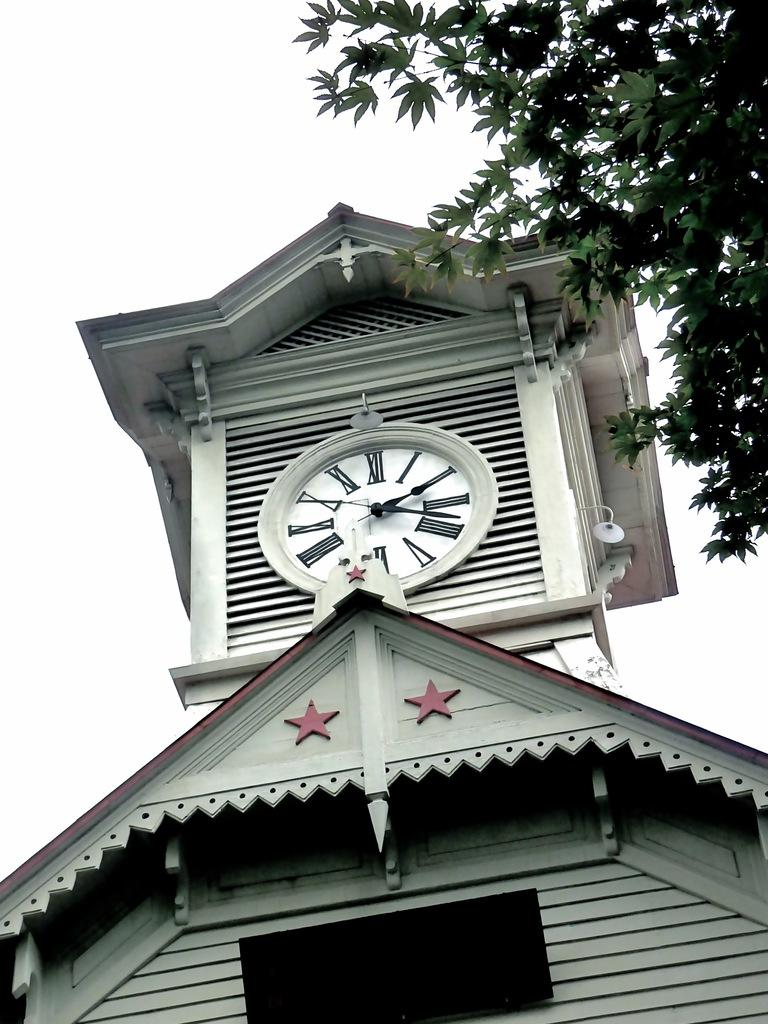Provide a one-sentence caption for the provided image. A courthouse type clock that says it is seventeen after two. 